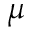<formula> <loc_0><loc_0><loc_500><loc_500>\mu</formula> 